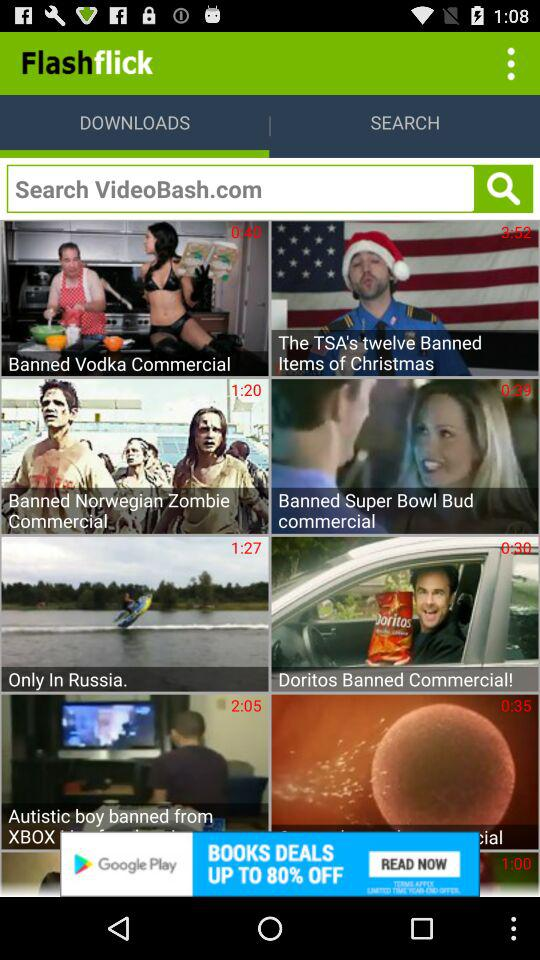What text is written in the search box? The text is "Search VideoBash.com". 